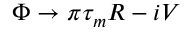Convert formula to latex. <formula><loc_0><loc_0><loc_500><loc_500>\Phi \to \pi \tau _ { m } R - i V</formula> 